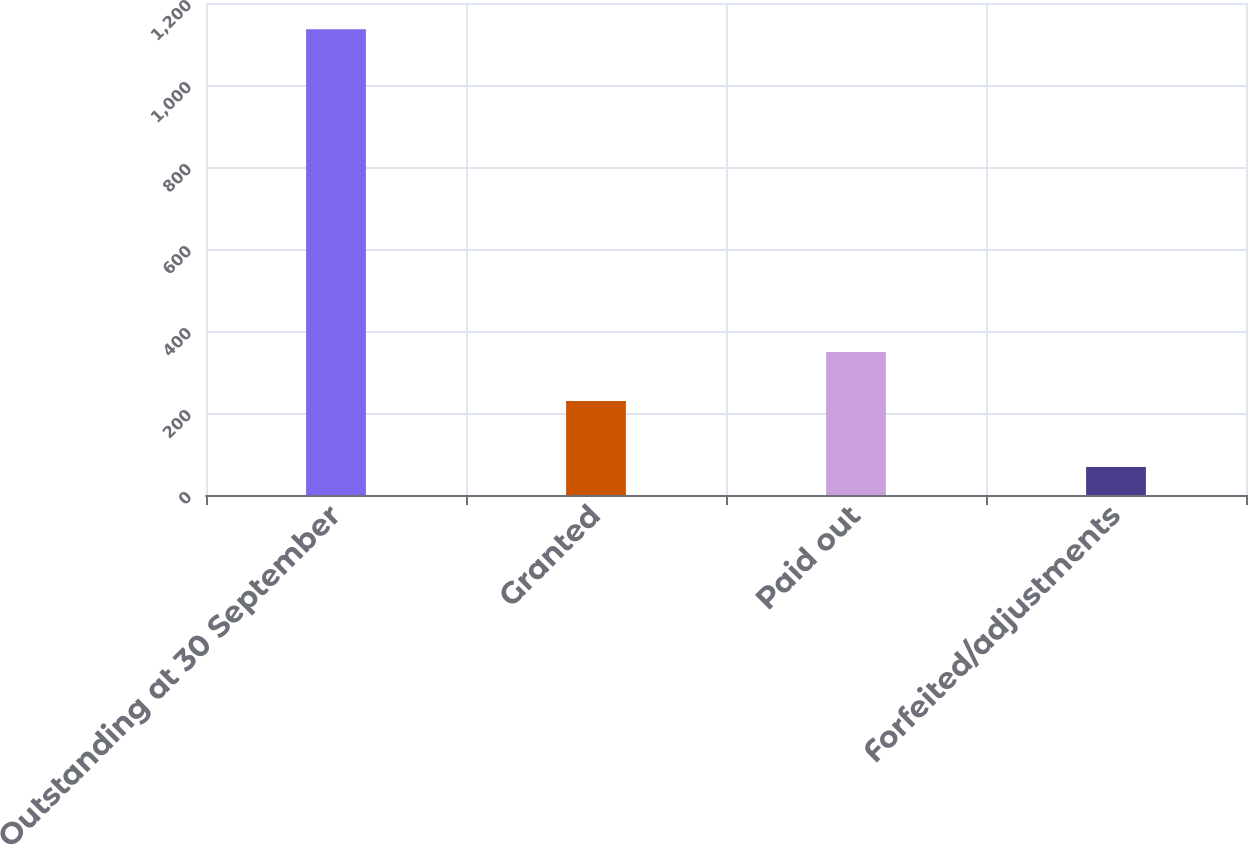Convert chart. <chart><loc_0><loc_0><loc_500><loc_500><bar_chart><fcel>Outstanding at 30 September<fcel>Granted<fcel>Paid out<fcel>Forfeited/adjustments<nl><fcel>1136<fcel>229<fcel>348.6<fcel>68<nl></chart> 